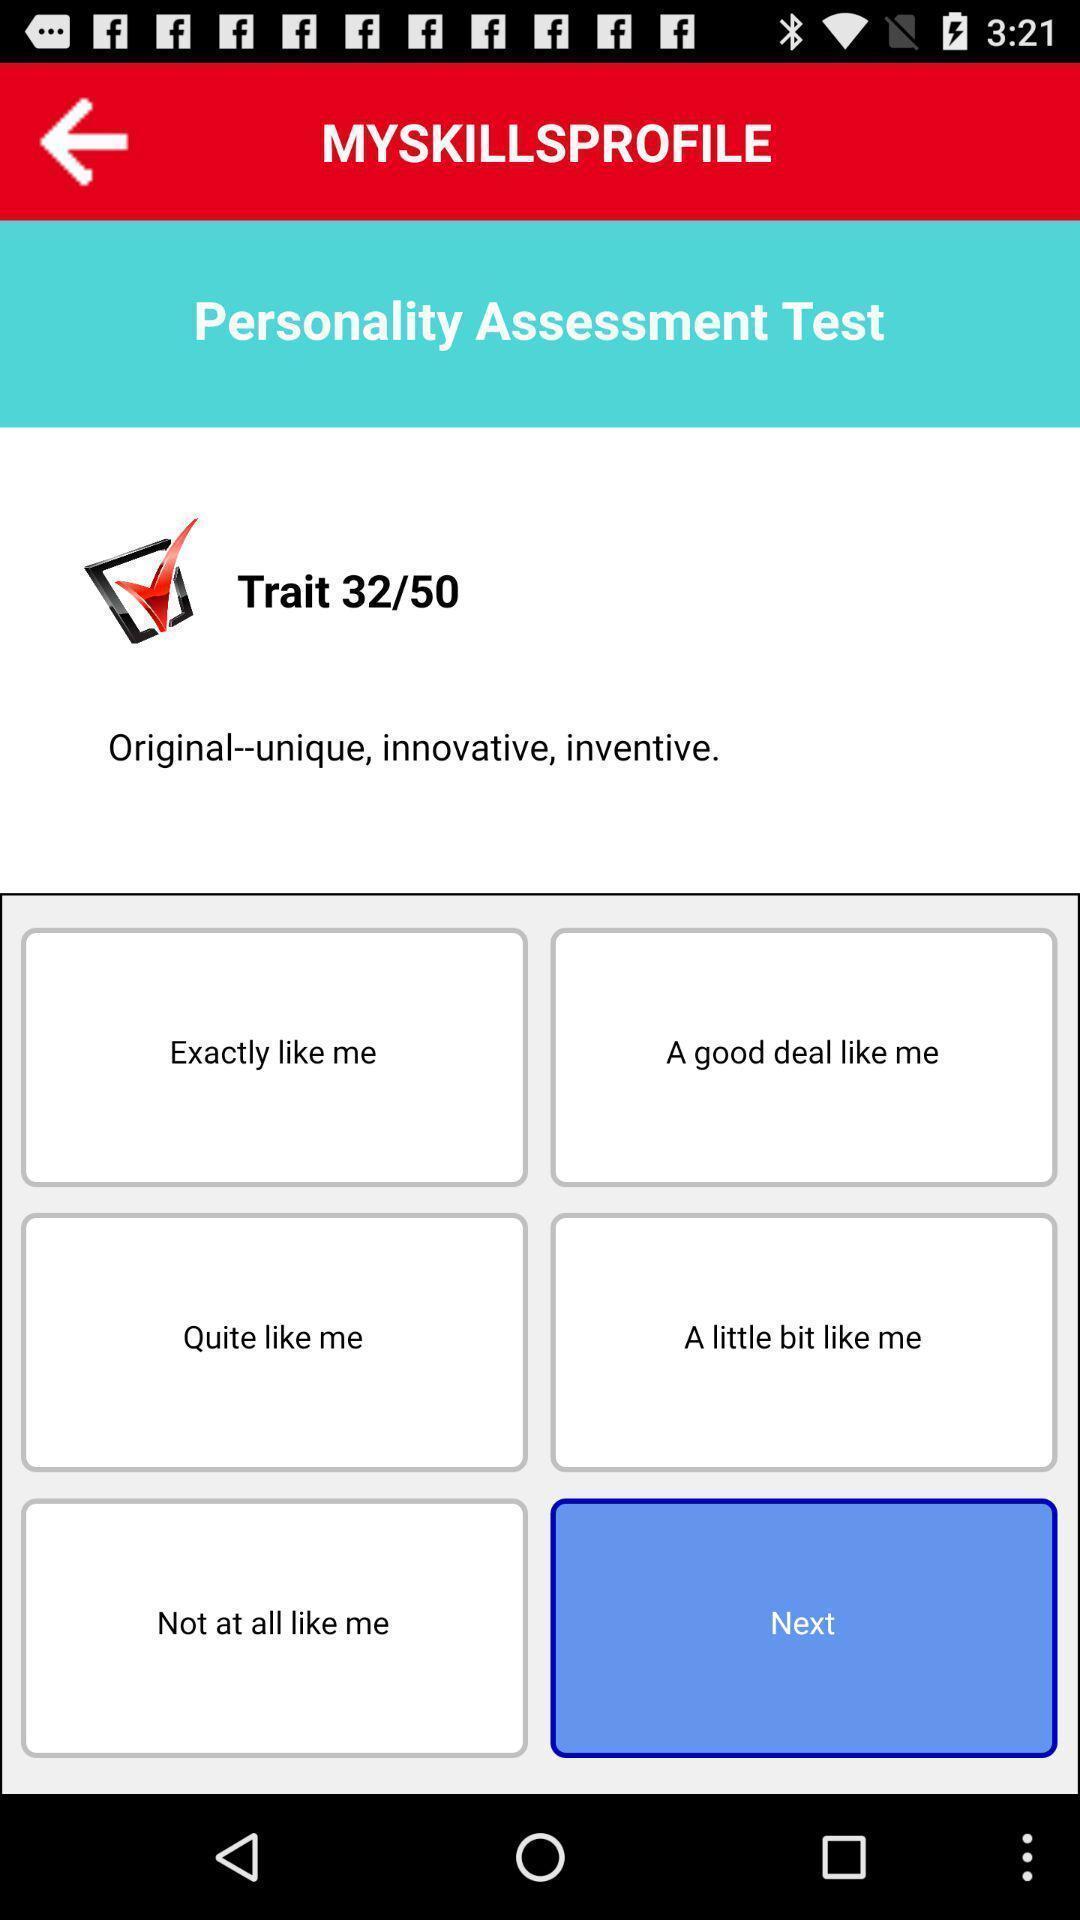Describe this image in words. Page showing personality assessment test app. 